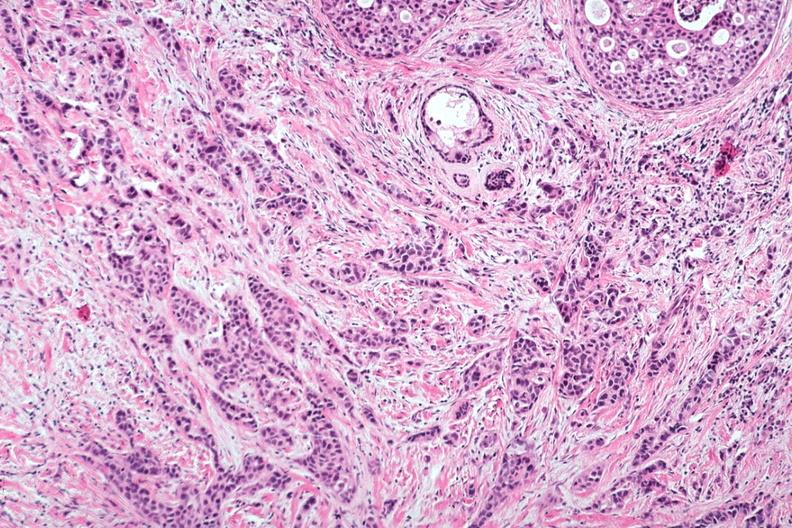how does this image show excellent invasive tumor?
Answer the question using a single word or phrase. With marked desmoplastic reaction 